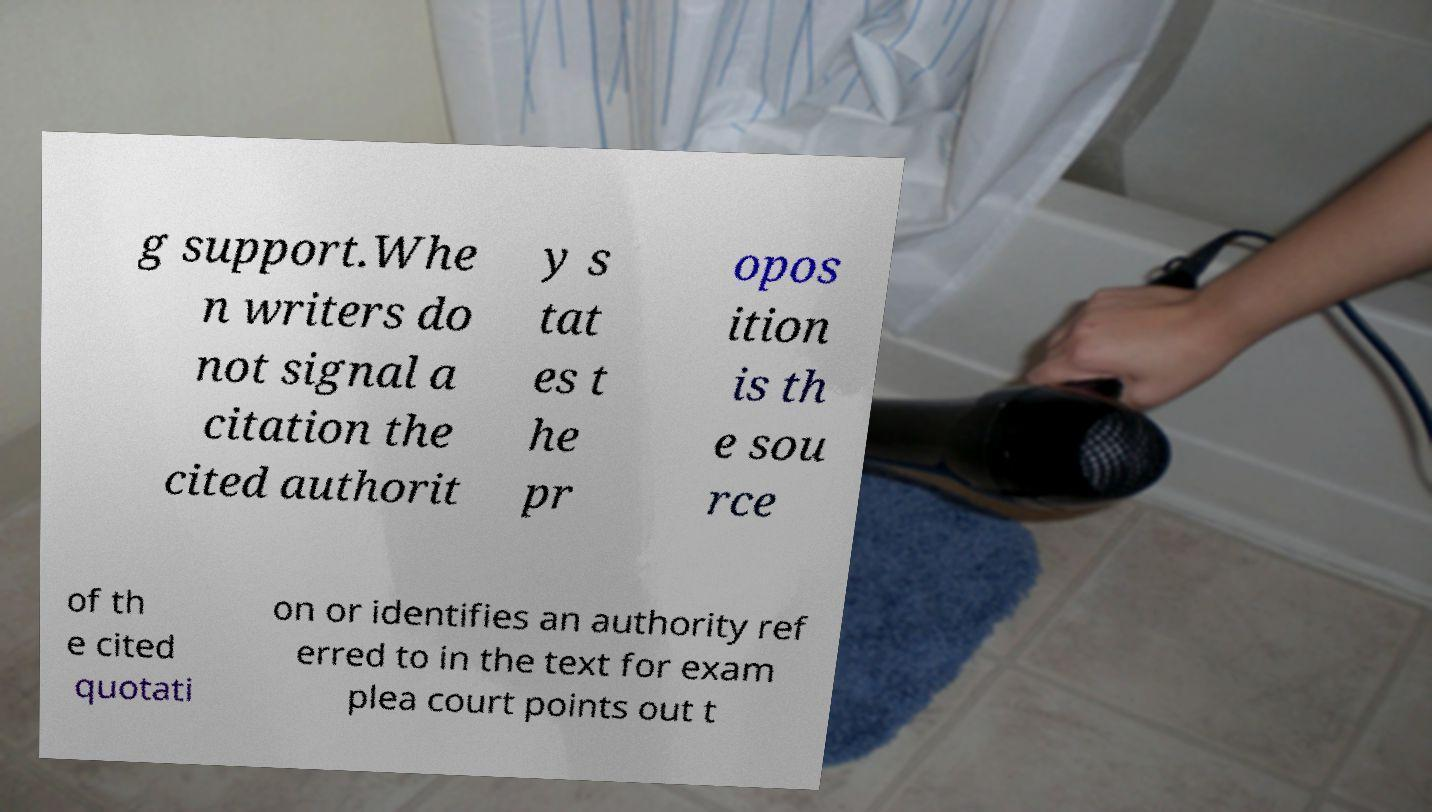Can you accurately transcribe the text from the provided image for me? g support.Whe n writers do not signal a citation the cited authorit y s tat es t he pr opos ition is th e sou rce of th e cited quotati on or identifies an authority ref erred to in the text for exam plea court points out t 